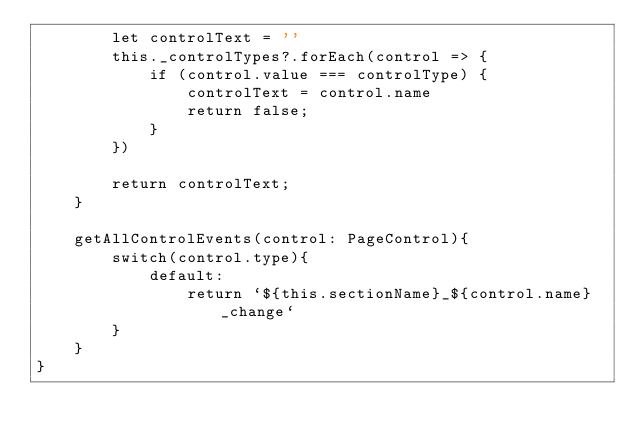Convert code to text. <code><loc_0><loc_0><loc_500><loc_500><_TypeScript_>        let controlText = ''
        this._controlTypes?.forEach(control => {
            if (control.value === controlType) {
                controlText = control.name
                return false;
            }
        })

        return controlText;
    }

    getAllControlEvents(control: PageControl){
        switch(control.type){
            default:
                return `${this.sectionName}_${control.name}_change`
        }
    }
}
</code> 